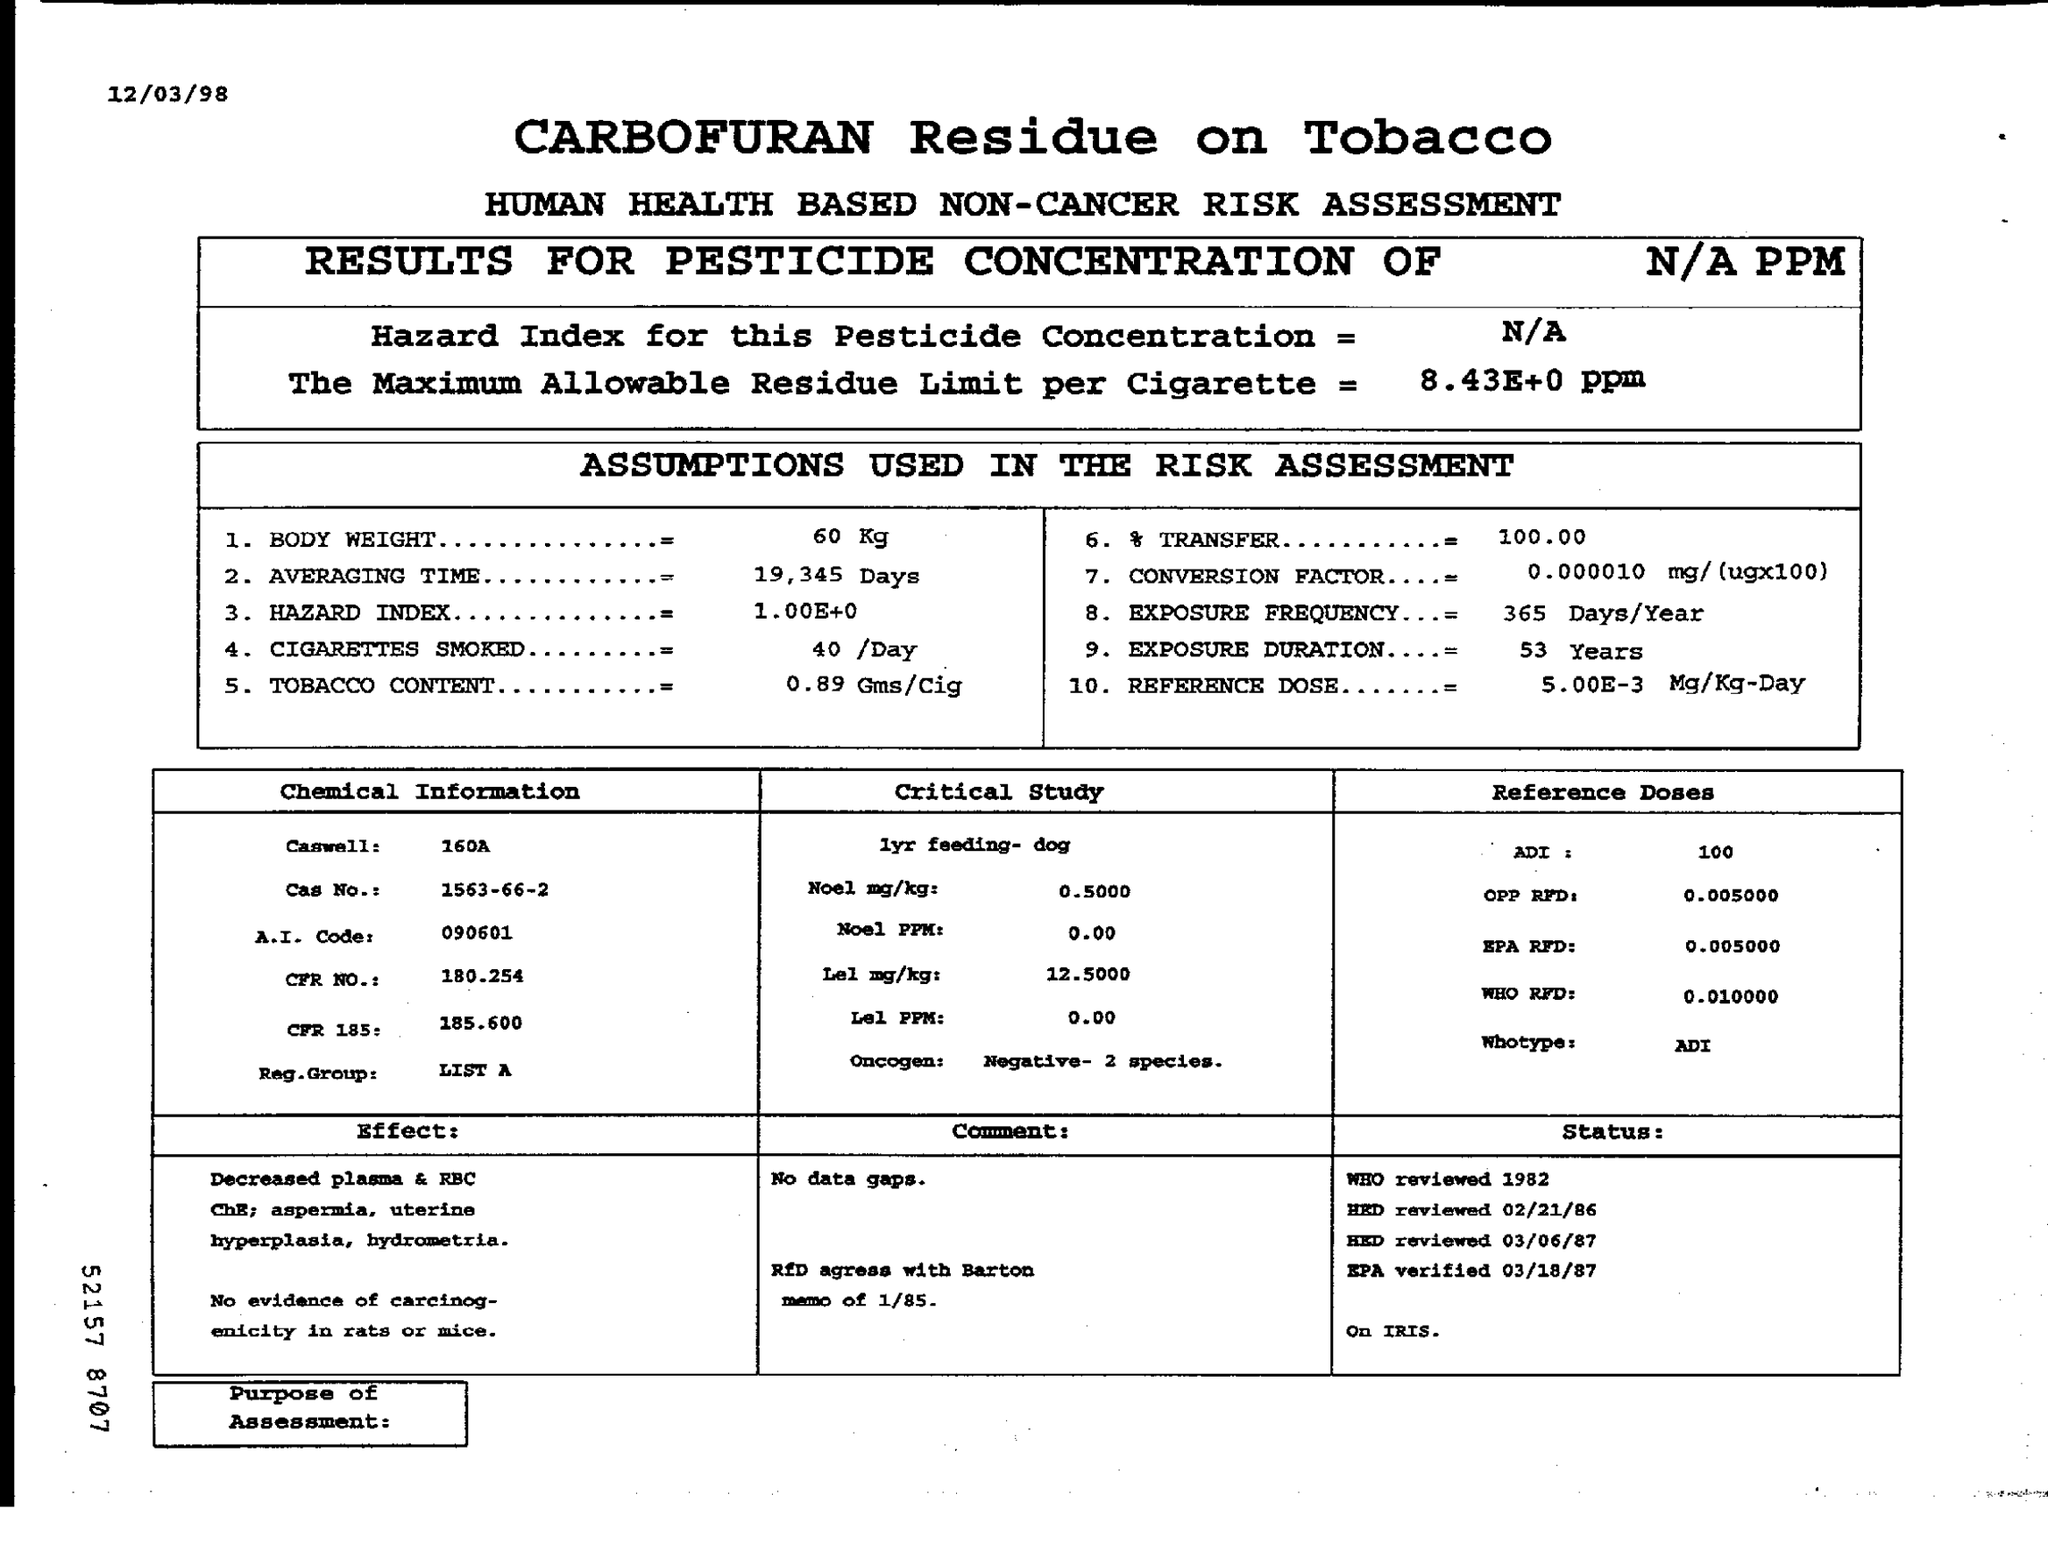Give some essential details in this illustration. The Hazard Index is a numerical value that represents the likelihood of a hazardous situation occurring. It is typically expressed as a range, with a minimum and maximum value representing the lowest and highest possible values, respectively. For example, the Hazard Index for a situation with a 1 in 100,000 chance of occurrence could range from 1.00E+0 to 1.00E+00. The title of the document is "CARBOFURAN Residue on Tobacco. The transfer is 100.00%. The tobacco content in this cigarette is 0.89 grams per cigarette. The hazard index for this pesticide concentration is not available. 